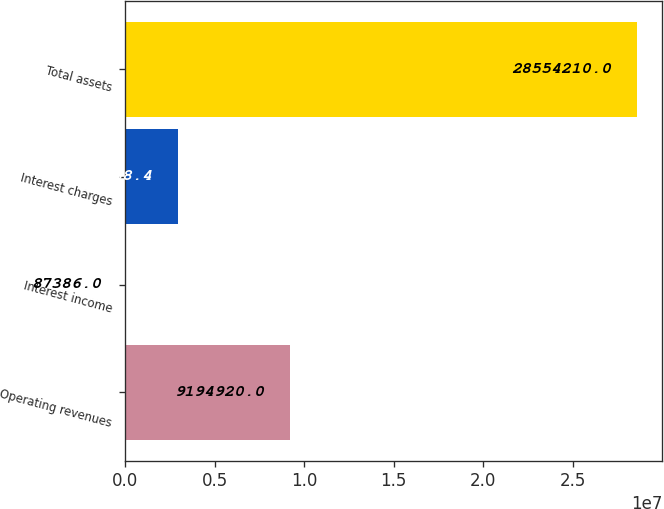Convert chart to OTSL. <chart><loc_0><loc_0><loc_500><loc_500><bar_chart><fcel>Operating revenues<fcel>Interest income<fcel>Interest charges<fcel>Total assets<nl><fcel>9.19492e+06<fcel>87386<fcel>2.93407e+06<fcel>2.85542e+07<nl></chart> 